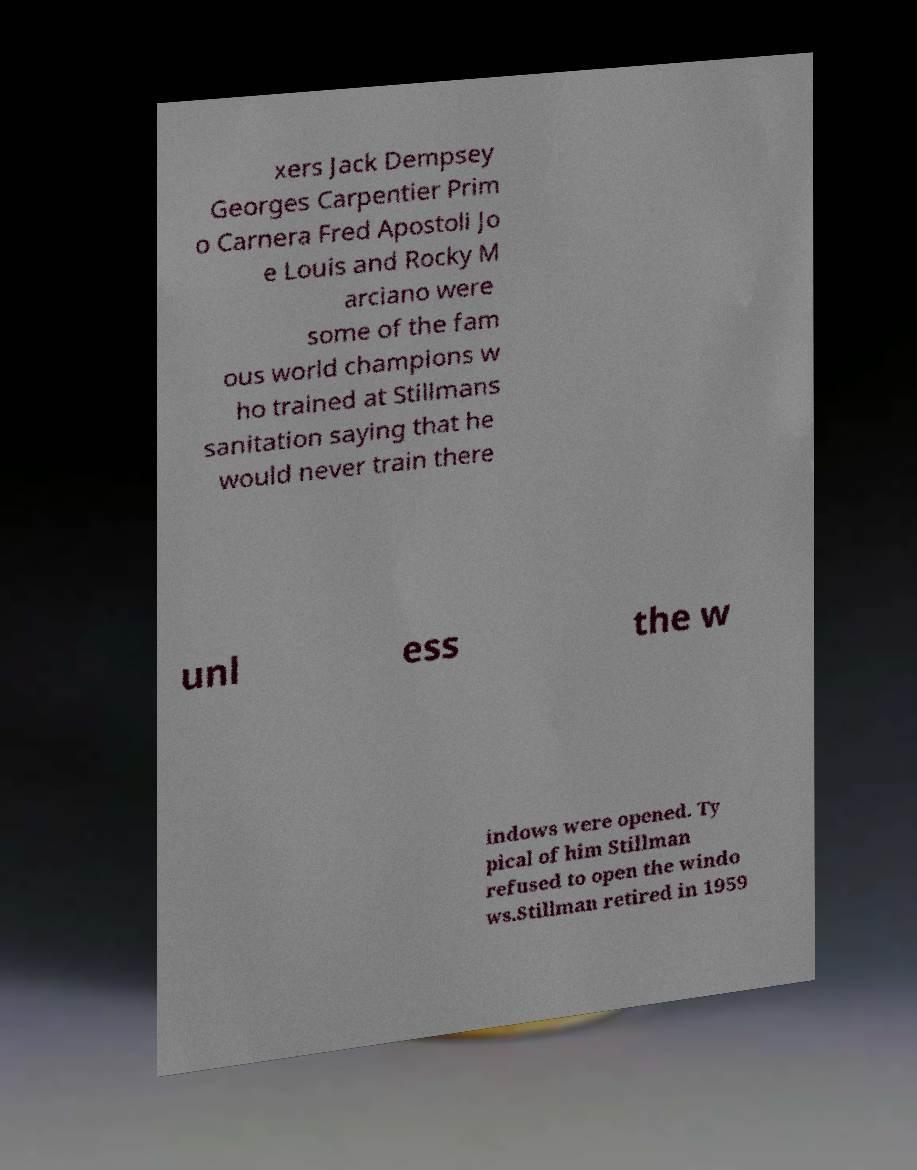Please identify and transcribe the text found in this image. xers Jack Dempsey Georges Carpentier Prim o Carnera Fred Apostoli Jo e Louis and Rocky M arciano were some of the fam ous world champions w ho trained at Stillmans sanitation saying that he would never train there unl ess the w indows were opened. Ty pical of him Stillman refused to open the windo ws.Stillman retired in 1959 